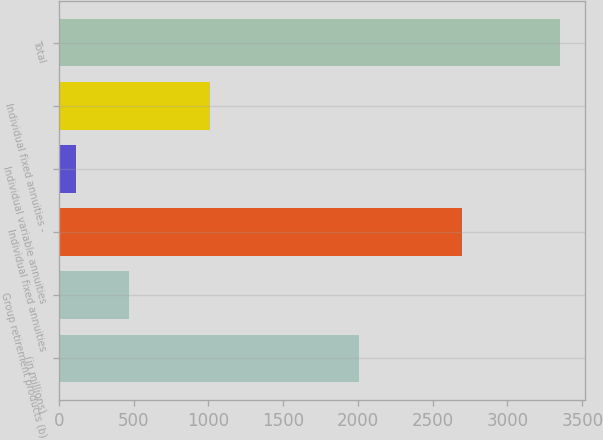<chart> <loc_0><loc_0><loc_500><loc_500><bar_chart><fcel>(in millions)<fcel>Group retirement products (b)<fcel>Individual fixed annuities<fcel>Individual variable annuities<fcel>Individual fixed annuities -<fcel>Total<nl><fcel>2006<fcel>467<fcel>2697<fcel>114<fcel>1009<fcel>3353<nl></chart> 